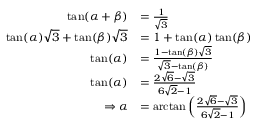Convert formula to latex. <formula><loc_0><loc_0><loc_500><loc_500>\begin{array} { r l } { \tan ( \alpha + \beta ) } & { = \frac { 1 } { \sqrt { 3 } } } \\ { \tan ( \alpha ) \sqrt { 3 } + \tan ( \beta ) \sqrt { 3 } } & { = 1 + \tan ( \alpha ) \tan ( \beta ) } \\ { \tan ( \alpha ) } & { = \frac { 1 - \tan ( \beta ) \sqrt { 3 } } { \sqrt { 3 } - \tan ( \beta ) } } \\ { \tan ( \alpha ) } & { = \frac { 2 \sqrt { 6 } - \sqrt { 3 } } { 6 \sqrt { 2 } - 1 } } \\ { \Rightarrow \alpha } & { = \arctan \left ( \frac { 2 \sqrt { 6 } - \sqrt { 3 } } { 6 \sqrt { 2 } - 1 } \right ) } \end{array}</formula> 